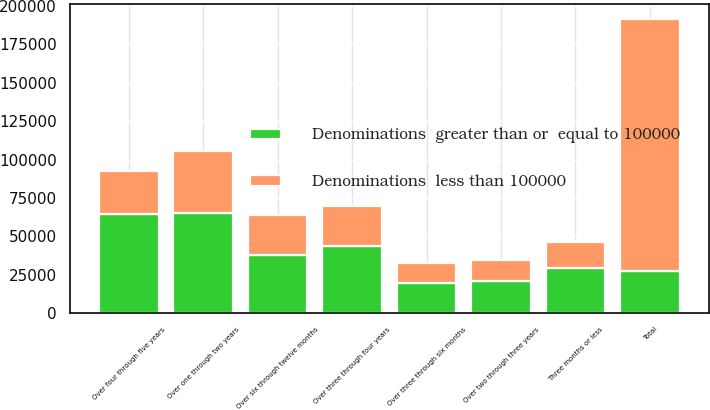<chart> <loc_0><loc_0><loc_500><loc_500><stacked_bar_chart><ecel><fcel>Three months or less<fcel>Over three through six months<fcel>Over six through twelve months<fcel>Over one through two years<fcel>Over two through three years<fcel>Over three through four years<fcel>Over four through five years<fcel>Total<nl><fcel>Denominations  greater than or  equal to 100000<fcel>29611<fcel>19714<fcel>37911<fcel>65051<fcel>21200<fcel>43654<fcel>64552<fcel>27812<nl><fcel>Denominations  less than 100000<fcel>16960<fcel>12716<fcel>26078<fcel>40434<fcel>13504<fcel>26245<fcel>27812<fcel>163749<nl></chart> 